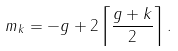Convert formula to latex. <formula><loc_0><loc_0><loc_500><loc_500>m _ { k } = - g + 2 \left \lceil \frac { g + k } { 2 } \right \rceil .</formula> 